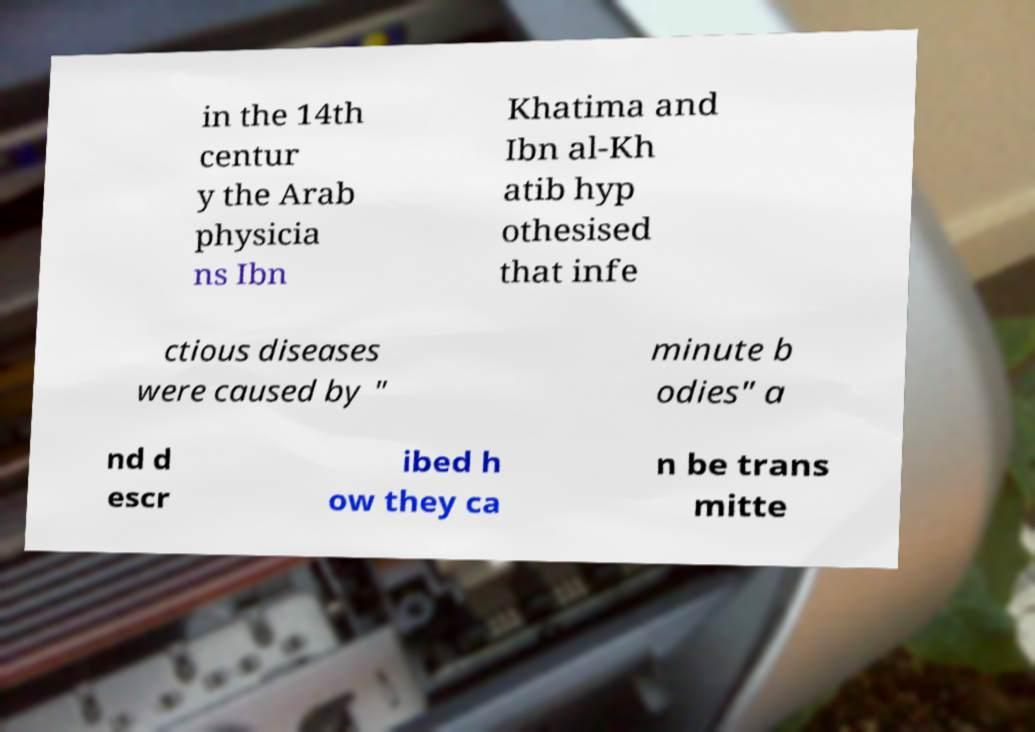Could you extract and type out the text from this image? in the 14th centur y the Arab physicia ns Ibn Khatima and Ibn al-Kh atib hyp othesised that infe ctious diseases were caused by " minute b odies" a nd d escr ibed h ow they ca n be trans mitte 